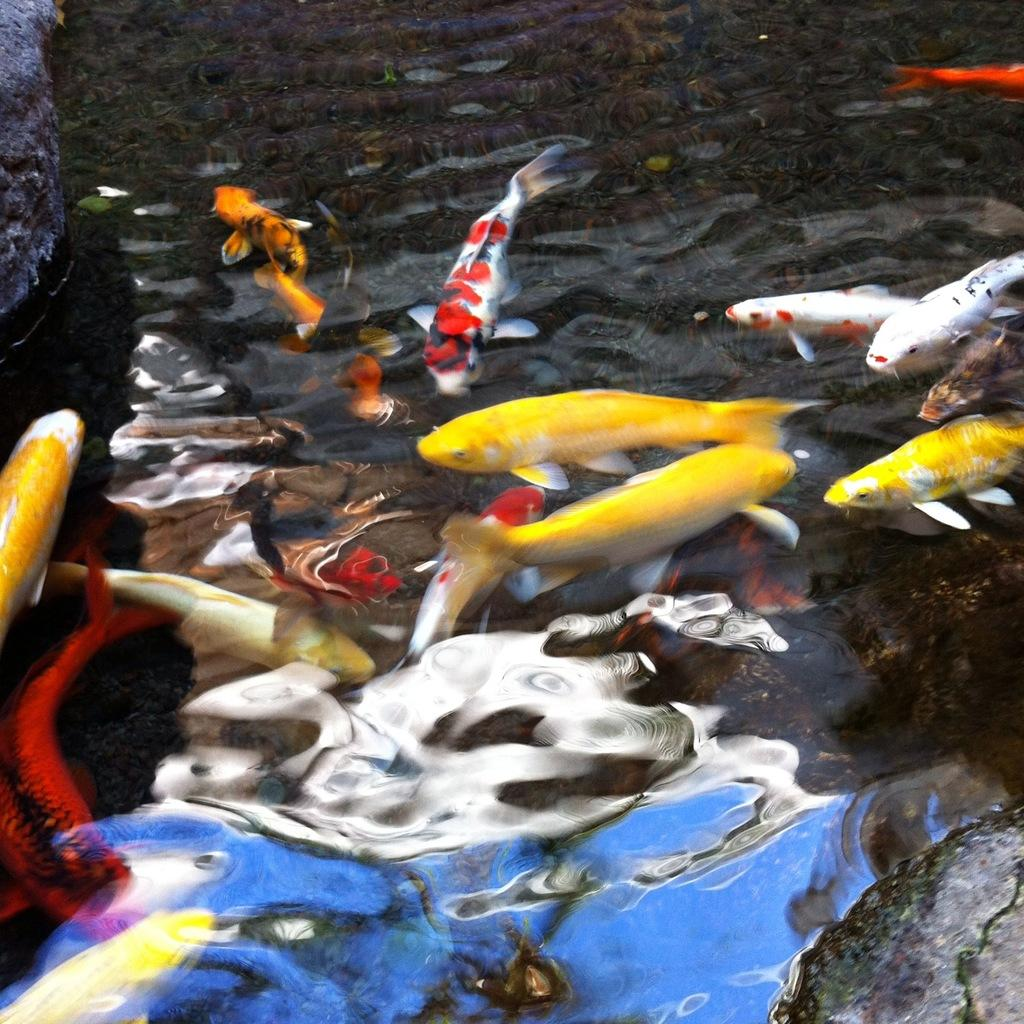What is the main subject in the center of the image? There is a pond in the center of the image. What can be found inside the pond? There are fishes in the pond. Where is the meeting taking place in the image? There is no meeting present in the image; it features a pond with fishes. Can you see any bats flying around in the image? There are no bats visible in the image. 